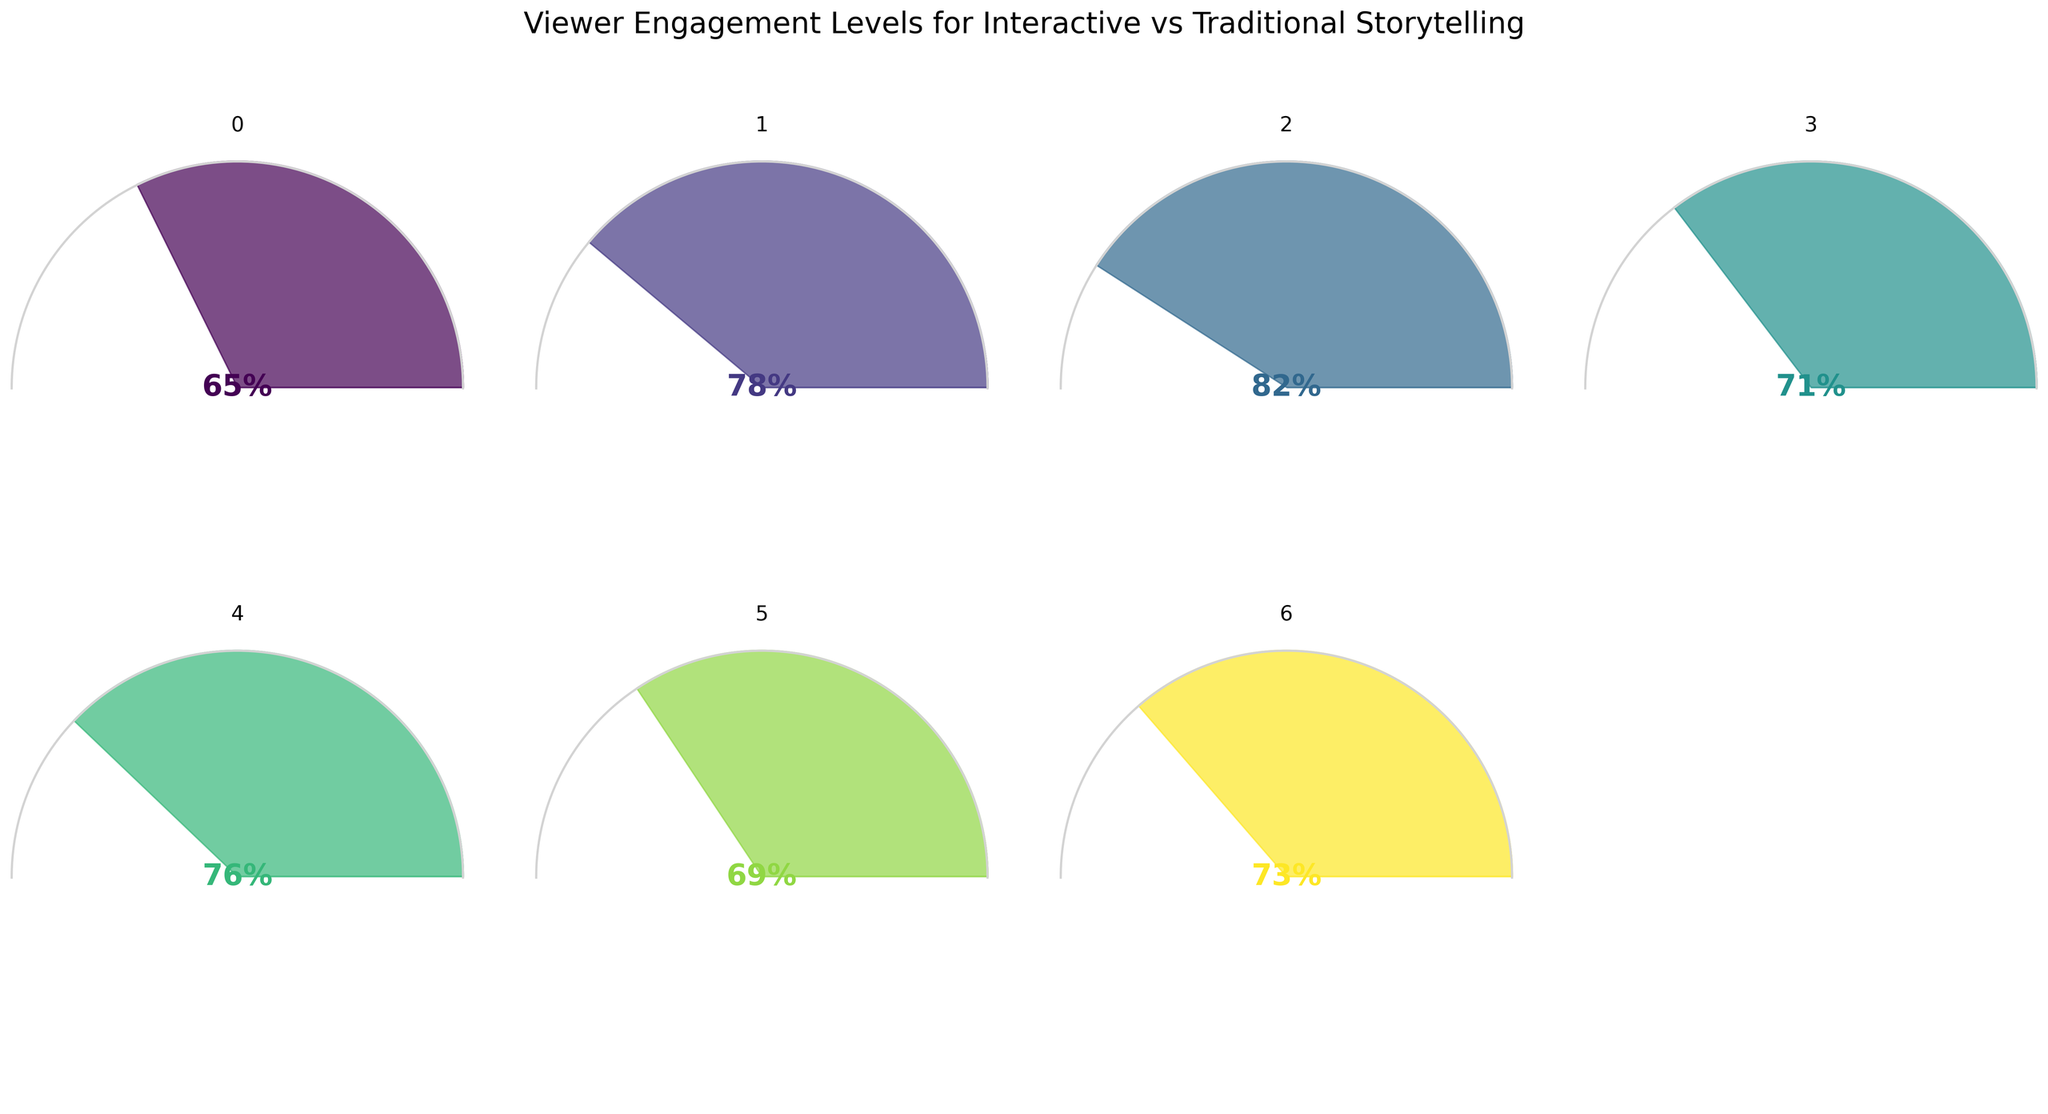What is the title of the figure? The title is typically found at the top of the figure and it describes the overall content or purpose of the figure. In this case, it summarizes the theme of the gauge charts, which is about comparing viewer engagement levels between two different storytelling formats.
Answer: Viewer Engagement Levels for Interactive vs Traditional Storytelling Which interactive narrative film has the highest viewer engagement level? By examining the individual gauge charts, you can identify which film has the highest percentage. In this case, it is the chart with the highest value.
Answer: Black Mirror: Bandersnatch How many narrative entries are compared in the figure? To find this, simply count the number of individual gauge charts presented in the figure. Each represents a different narrative entry.
Answer: 7 What's the difference in viewer engagement levels between 'Traditional Linear Films' and 'Interactive Narrative Films'? First, locate the values for both 'Traditional Linear Films' and 'Interactive Narrative Films'. Then, subtract the value of 'Traditional Linear Films' from the value of 'Interactive Narrative Films'.
Answer: 13% What is the average viewer engagement level of the interactive narrative films (including 'Black Mirror: Bandersnatch', 'Late Shift', 'Her Story', and 'Mosaic')? Add up the values of all the interactive narrative films and divide by the number of films. (82 + 71 + 76 + 69) / 4 = 74.5
Answer: 74.5% Which storytelling format shows the lowest engagement level? Compare the lowest value from interactive narrative films and traditional linear storytelling. The film or format with the lowest value will have the least engagement.
Answer: Traditional Linear Films Is the viewer engagement level for 'Her Story' higher or lower than 'Choose Your Own Adventure Books'? Look at the values for both ‘Her Story’ and ‘Choose Your Own Adventure Books’, and compare them directly to determine which is higher.
Answer: Lower What percentage value is located at the center of the gauge chart for 'Mosaic'? This can be found at the center of the gauge chart that represents 'Mosaic', usually written in large, prominent text.
Answer: 69% Which interactive film's engagement level is closest to the overall engagement level of 'Interactive Narrative Films'? Identify the value for ‘Interactive Narrative Films’, then compare it against the values of individual interactive films to see which one is numerically closest.
Answer: Her Story Is any interactive narrative film engagement level exactly the same as 'Traditional Linear Films'? Check the engagement value of 'Traditional Linear Films' and see if any interactive film has the exact same value.
Answer: No 